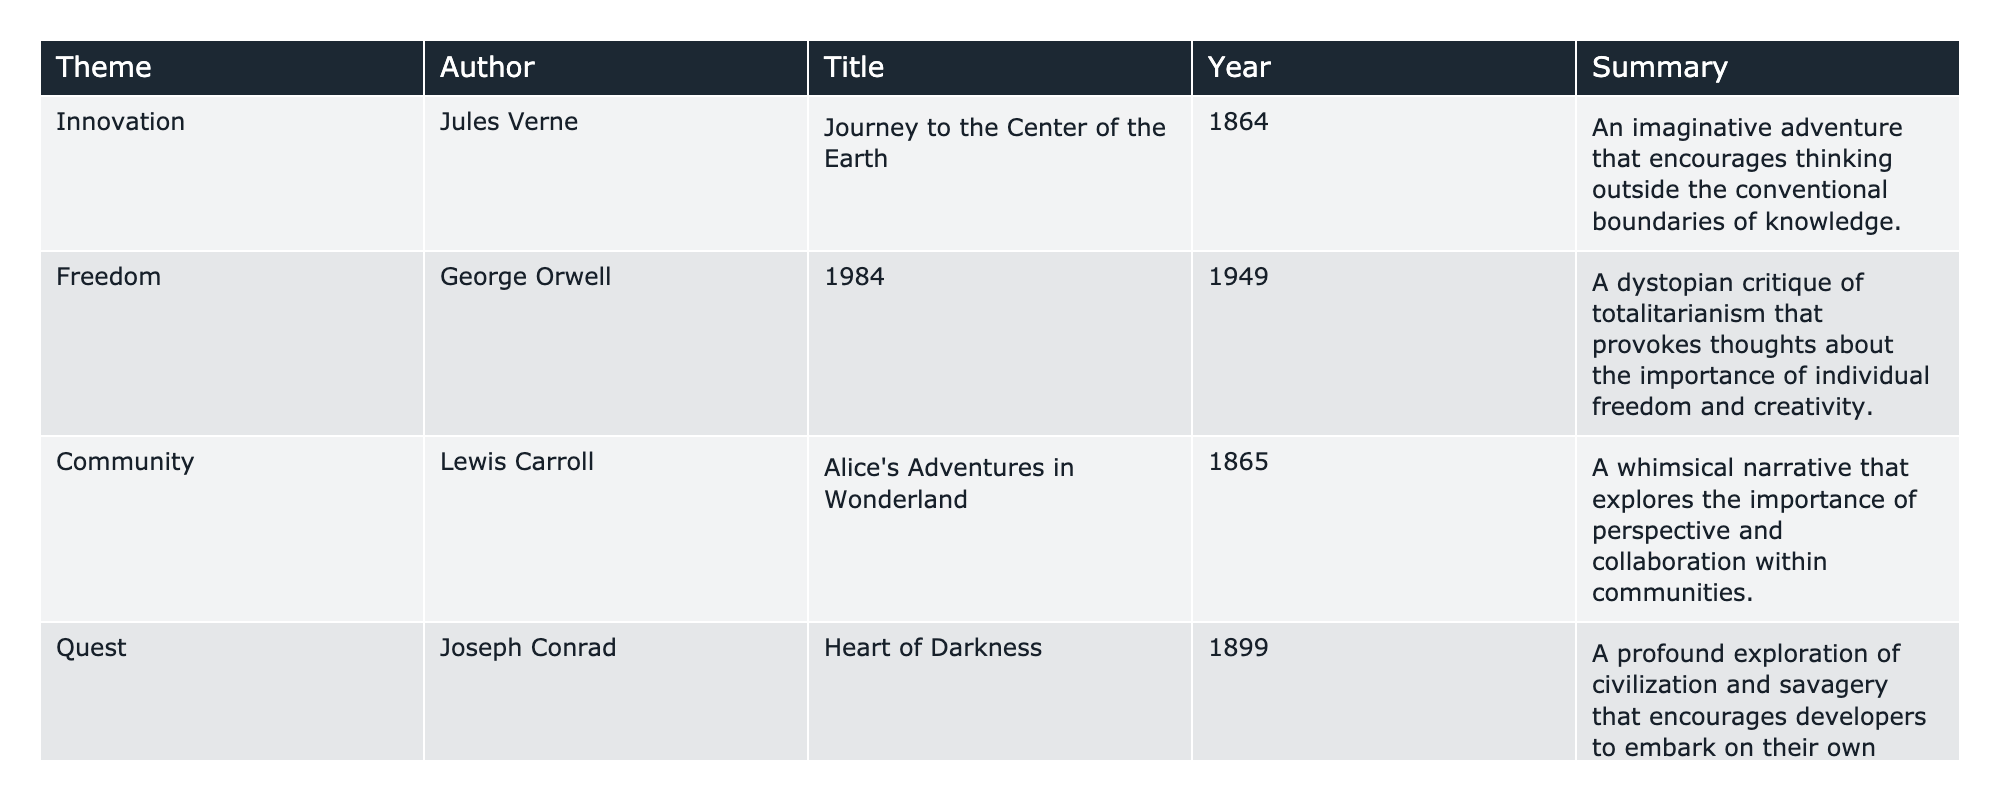What is the title of the book written by Jules Verne? The table lists Jules Verne as the author, and the corresponding title in his row is "Journey to the Center of the Earth."
Answer: Journey to the Center of the Earth Which author wrote about the theme of Freedom? From the table, George Orwell is associated with the theme of Freedom, and his book is "1984."
Answer: George Orwell How many books focus on the theme of Community? The table shows one book focusing on Community, which is "Alice's Adventures in Wonderland" by Lewis Carroll.
Answer: 1 What is the year of publication for "Heart of Darkness"? The table indicates that "Heart of Darkness" by Joseph Conrad was published in 1899, as shown in the corresponding row.
Answer: 1899 Is "The Great God Pan" associated with the theme of Innovation? Referring to the table, "The Great God Pan" is linked to the theme of Fantasy, not Innovation, hence this statement is false.
Answer: No What are the themes represented by books published in the 1860s? "Journey to the Center of the Earth" and "Alice's Adventures in Wonderland" are both published in the 1860s, corresponding to the themes of Innovation and Community, respectively.
Answer: Innovation, Community How many authors in the table wrote about Quest or Fantasy? The table shows that Joseph Conrad wrote about Quest and Arthur Machen focused on Fantasy, totaling two authors who wrote about these themes.
Answer: 2 Which author has the latest publication date, and what is the title of their book? The latest publication date is 1949 for George Orwell, whose book is entitled "1984," as per the information in the table.
Answer: 1984 List the titles of the books that explore themes related to knowledge and creativity. "Journey to the Center of the Earth" and "1984" delve into themes of knowledge and creativity, as indicated by their summaries.
Answer: Journey to the Center of the Earth, 1984 What is the common characteristic of the books associated with the themes of Quest and Fantasy? Both "Heart of Darkness" and "The Great God Pan" encourage exploration and embrace the unknown, as expressed in their summaries in the table.
Answer: Exploration and embrace of the unknown 